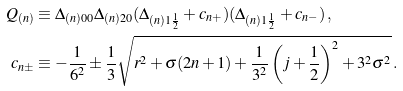Convert formula to latex. <formula><loc_0><loc_0><loc_500><loc_500>Q _ { ( n ) } & \equiv \Delta _ { ( n ) 0 0 } \Delta _ { ( n ) 2 0 } ( \Delta _ { ( n ) 1 \frac { 1 } { 2 } } + c _ { n + } ) ( \Delta _ { ( n ) 1 \frac { 1 } { 2 } } + c _ { n - } ) \, , \\ c _ { n \pm } & \equiv - \frac { 1 } { 6 ^ { 2 } } \pm \frac { 1 } { 3 } \sqrt { r ^ { 2 } + \sigma ( 2 n + 1 ) + \frac { 1 } { 3 ^ { 2 } } \left ( j + \frac { 1 } { 2 } \right ) ^ { 2 } + 3 ^ { 2 } \sigma ^ { 2 } } \, .</formula> 